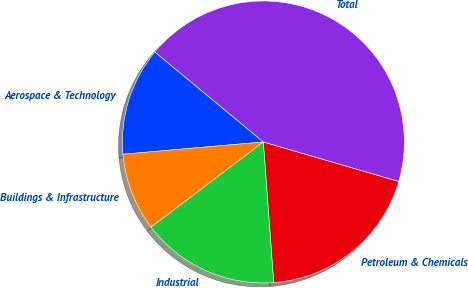Convert chart to OTSL. <chart><loc_0><loc_0><loc_500><loc_500><pie_chart><fcel>Aerospace & Technology<fcel>Buildings & Infrastructure<fcel>Industrial<fcel>Petroleum & Chemicals<fcel>Total<nl><fcel>12.4%<fcel>8.94%<fcel>15.85%<fcel>19.31%<fcel>43.5%<nl></chart> 